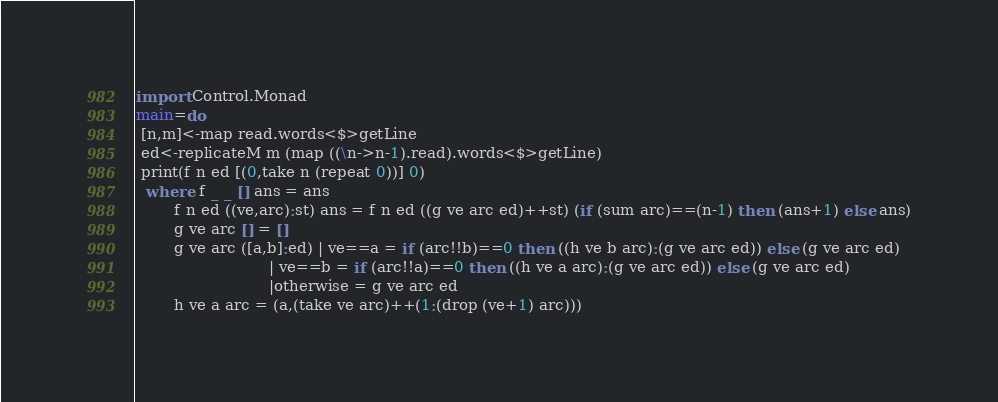<code> <loc_0><loc_0><loc_500><loc_500><_Haskell_>import Control.Monad
main=do
 [n,m]<-map read.words<$>getLine
 ed<-replicateM m (map ((\n->n-1).read).words<$>getLine)
 print(f n ed [(0,take n (repeat 0))] 0)
  where f _ _ [] ans = ans
        f n ed ((ve,arc):st) ans = f n ed ((g ve arc ed)++st) (if (sum arc)==(n-1) then (ans+1) else ans)
        g ve arc [] = []
        g ve arc ([a,b]:ed) | ve==a = if (arc!!b)==0 then ((h ve b arc):(g ve arc ed)) else (g ve arc ed)
                            | ve==b = if (arc!!a)==0 then ((h ve a arc):(g ve arc ed)) else (g ve arc ed)
                            |otherwise = g ve arc ed
        h ve a arc = (a,(take ve arc)++(1:(drop (ve+1) arc)))</code> 